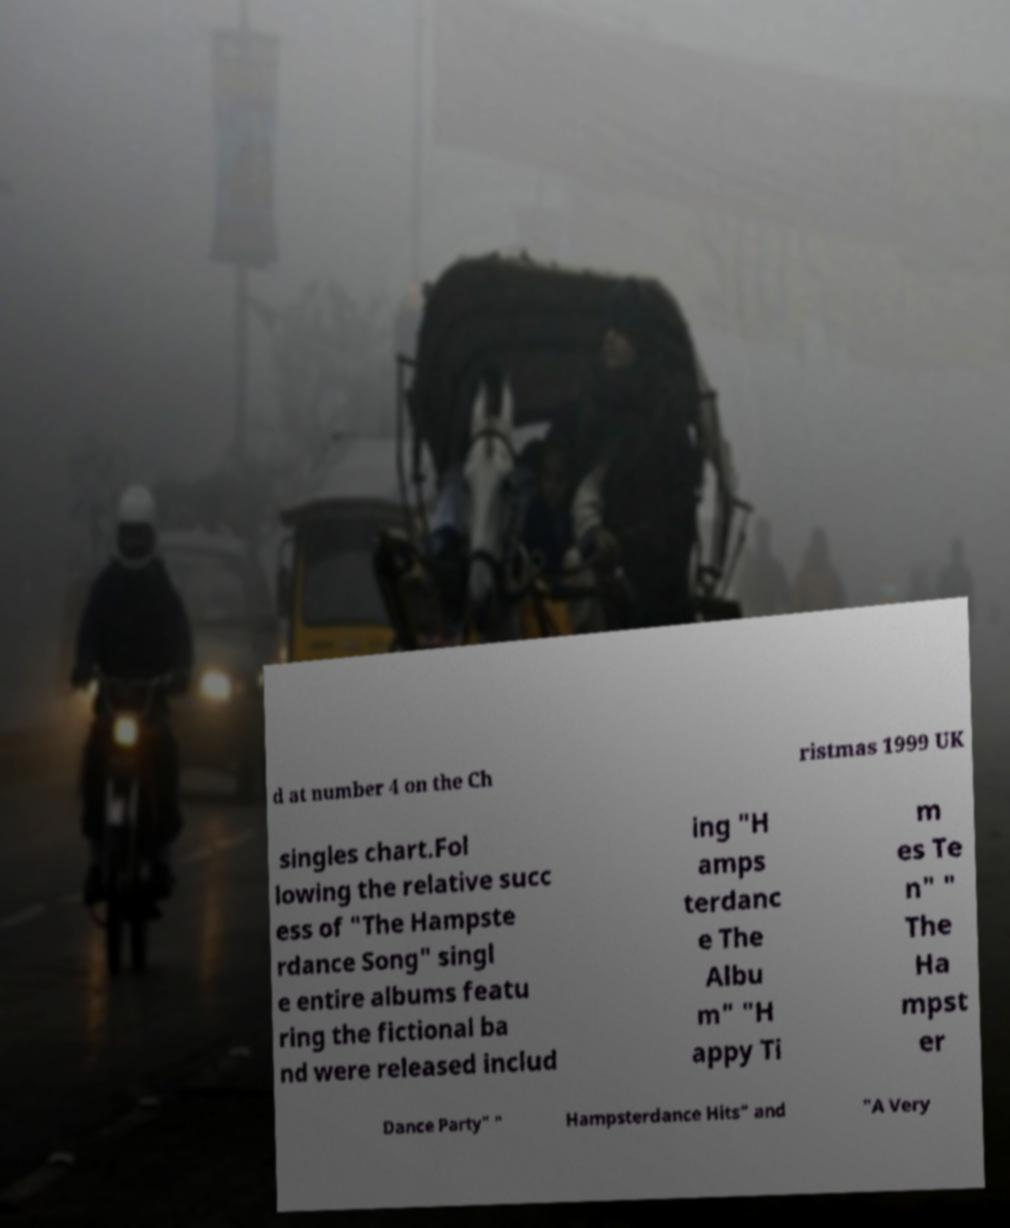There's text embedded in this image that I need extracted. Can you transcribe it verbatim? d at number 4 on the Ch ristmas 1999 UK singles chart.Fol lowing the relative succ ess of "The Hampste rdance Song" singl e entire albums featu ring the fictional ba nd were released includ ing "H amps terdanc e The Albu m" "H appy Ti m es Te n" " The Ha mpst er Dance Party" " Hampsterdance Hits" and "A Very 